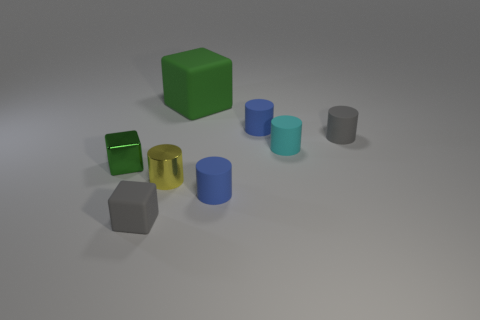Subtract all small gray matte cylinders. How many cylinders are left? 4 Subtract all gray cylinders. How many cylinders are left? 4 Subtract all purple cylinders. Subtract all blue cubes. How many cylinders are left? 5 Add 2 big gray objects. How many objects exist? 10 Subtract all cubes. How many objects are left? 5 Add 8 small red blocks. How many small red blocks exist? 8 Subtract 0 purple balls. How many objects are left? 8 Subtract all tiny blue matte cylinders. Subtract all blue matte cylinders. How many objects are left? 4 Add 6 small gray matte blocks. How many small gray matte blocks are left? 7 